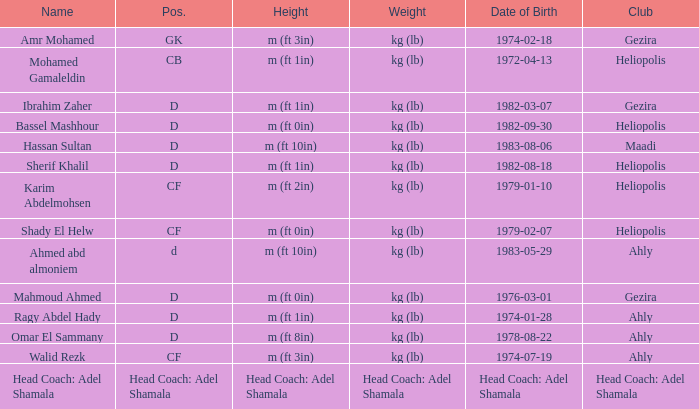When was the person born whose height is mentioned as "head coach: adel shamala"? Head Coach: Adel Shamala. 